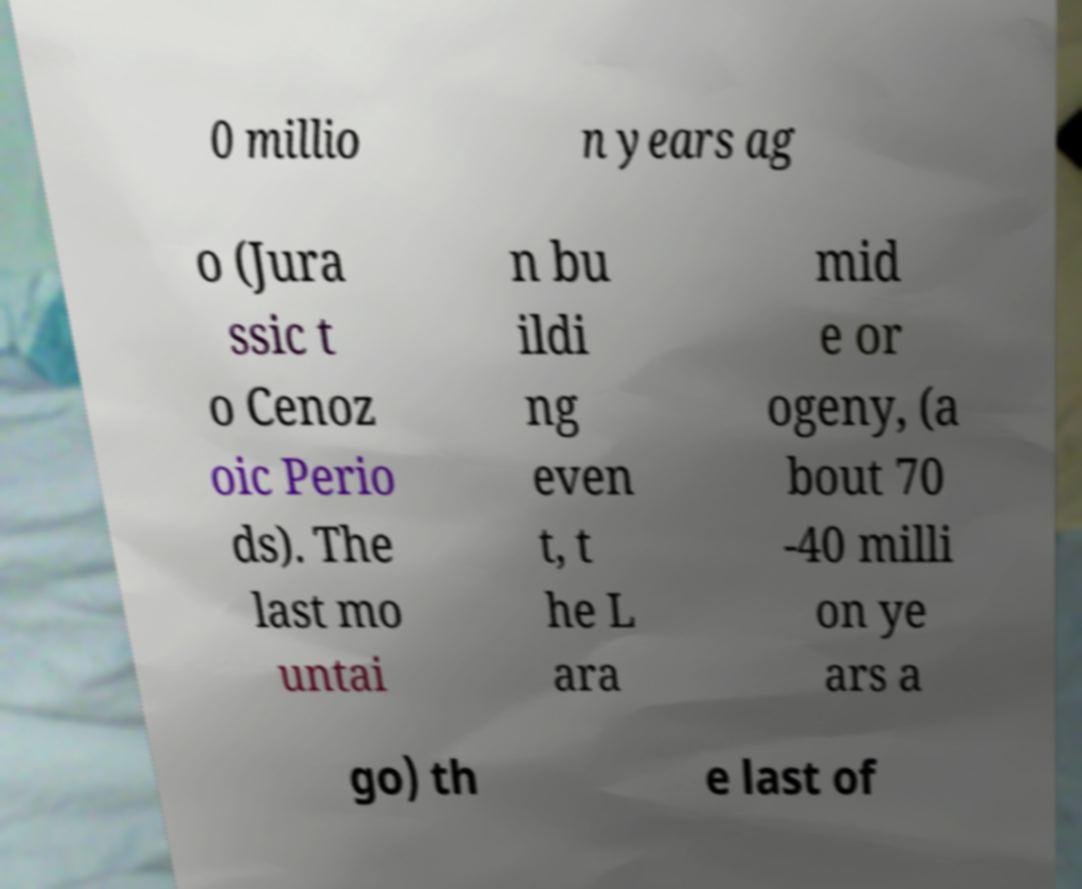Could you assist in decoding the text presented in this image and type it out clearly? 0 millio n years ag o (Jura ssic t o Cenoz oic Perio ds). The last mo untai n bu ildi ng even t, t he L ara mid e or ogeny, (a bout 70 -40 milli on ye ars a go) th e last of 